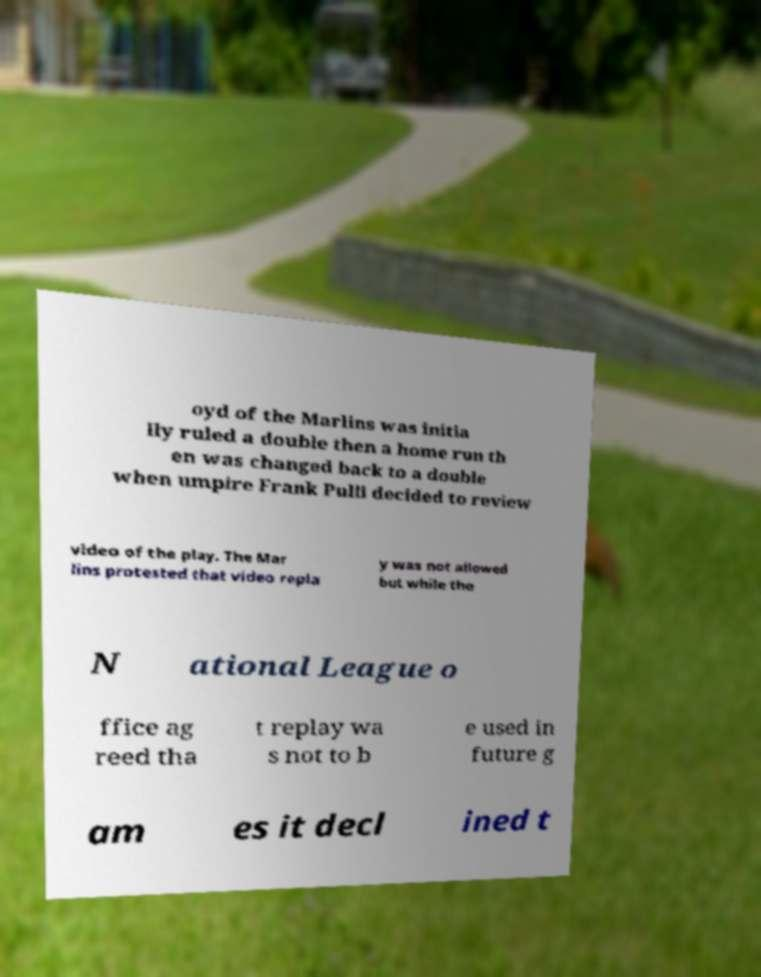Could you assist in decoding the text presented in this image and type it out clearly? oyd of the Marlins was initia lly ruled a double then a home run th en was changed back to a double when umpire Frank Pulli decided to review video of the play. The Mar lins protested that video repla y was not allowed but while the N ational League o ffice ag reed tha t replay wa s not to b e used in future g am es it decl ined t 